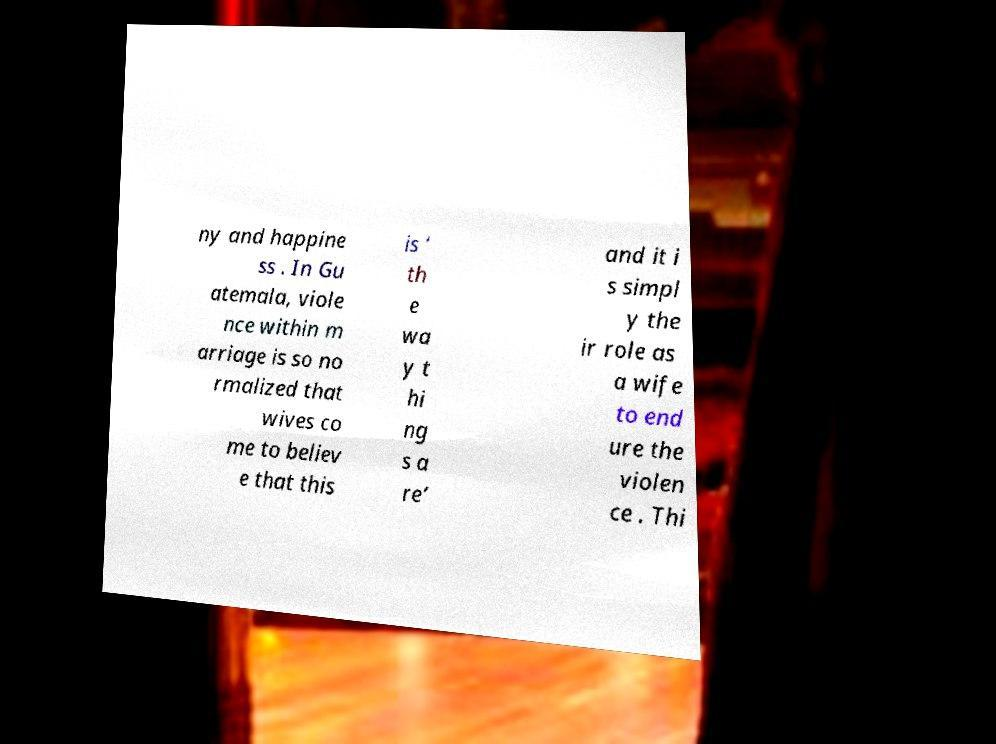What messages or text are displayed in this image? I need them in a readable, typed format. ny and happine ss . In Gu atemala, viole nce within m arriage is so no rmalized that wives co me to believ e that this is ‘ th e wa y t hi ng s a re’ and it i s simpl y the ir role as a wife to end ure the violen ce . Thi 